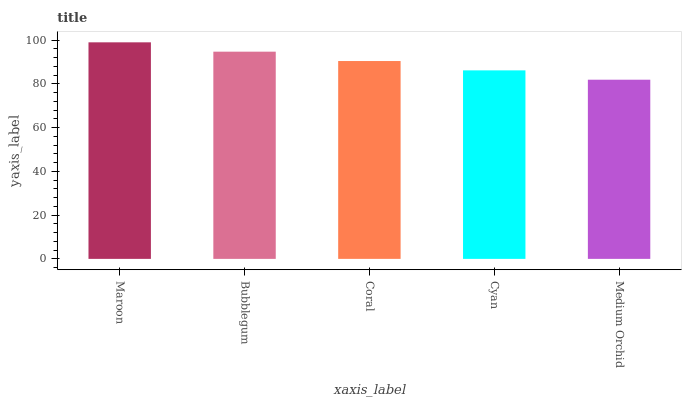Is Medium Orchid the minimum?
Answer yes or no. Yes. Is Maroon the maximum?
Answer yes or no. Yes. Is Bubblegum the minimum?
Answer yes or no. No. Is Bubblegum the maximum?
Answer yes or no. No. Is Maroon greater than Bubblegum?
Answer yes or no. Yes. Is Bubblegum less than Maroon?
Answer yes or no. Yes. Is Bubblegum greater than Maroon?
Answer yes or no. No. Is Maroon less than Bubblegum?
Answer yes or no. No. Is Coral the high median?
Answer yes or no. Yes. Is Coral the low median?
Answer yes or no. Yes. Is Maroon the high median?
Answer yes or no. No. Is Maroon the low median?
Answer yes or no. No. 